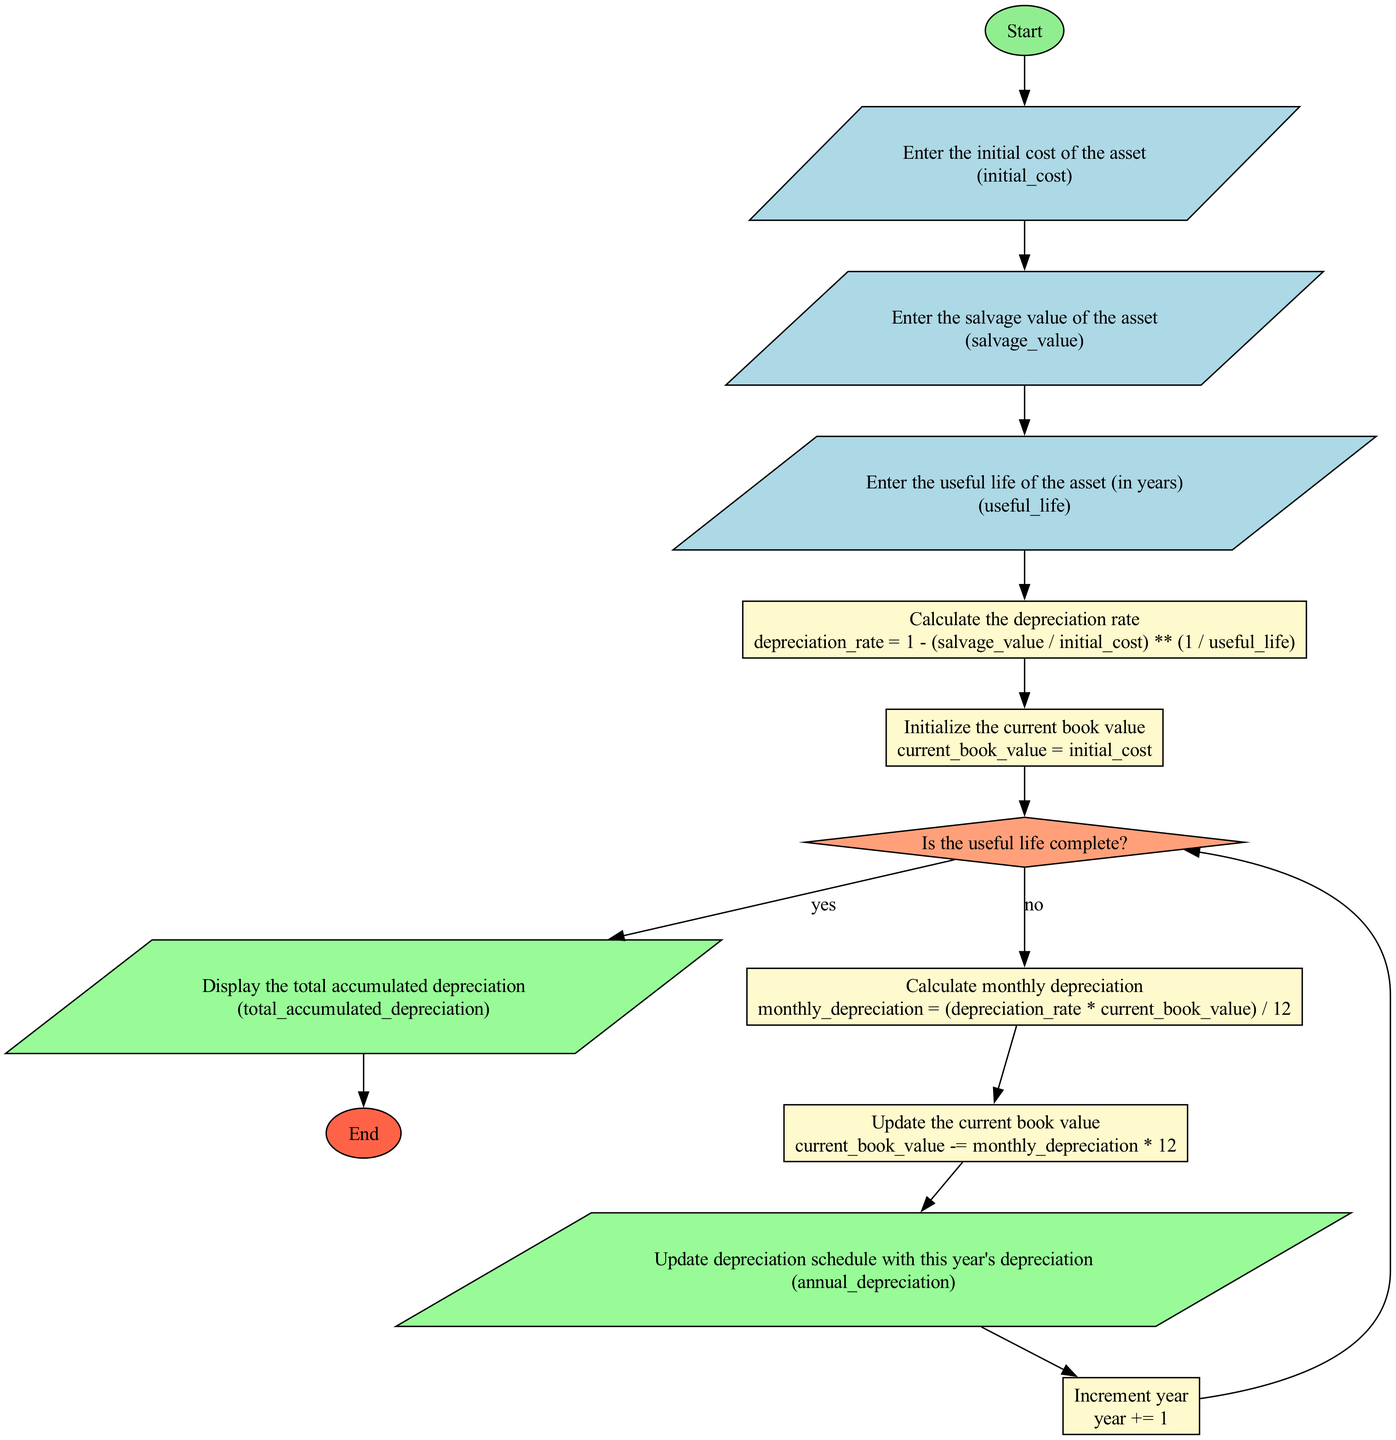What is the first input required in the flowchart? The first input required in the flowchart is the initial cost of the asset, as indicated by the input node labeled "Enter the initial cost of the asset".
Answer: initial cost What happens after entering the useful life of the asset? After entering the useful life of the asset, the process node labeled "Calculate the depreciation rate" is executed, where the depreciation rate is calculated based on the initial cost, salvage value, and useful life.
Answer: Calculate the depreciation rate How many output nodes are there in the flowchart? There are two output nodes in the flowchart, labeled "Display the total accumulated depreciation" and "Update depreciation schedule with this year's depreciation".
Answer: two What is the condition checked at the decision node? The condition checked at the decision node is whether the useful life is complete, specifically "Is the useful life complete?"
Answer: Is the useful life complete? What is the formula used to calculate monthly depreciation? The formula used to calculate monthly depreciation is "(depreciation_rate * current_book_value) / 12", which is outlined in the process node labeled "Calculate monthly depreciation".
Answer: (depreciation_rate * current_book_value) / 12 Where does the flow go if the useful life is complete? If the useful life is complete (answering "yes" to the decision node), the flow goes to the output node labeled "Display the total accumulated depreciation", indicating the end of the calculation.
Answer: Display the total accumulated depreciation How is the current book value updated? The current book value is updated by subtracting the annual depreciation from the current book value in the process node labeled "Update the current book value", using the formula "current_book_value -= monthly_depreciation * 12".
Answer: current_book_value -= monthly_depreciation * 12 What happens to the year variable in the flowchart? The year variable is incremented by 1 in the process node labeled "Increment year", allowing the calculation to proceed to the next year until the useful life is complete.
Answer: year += 1 